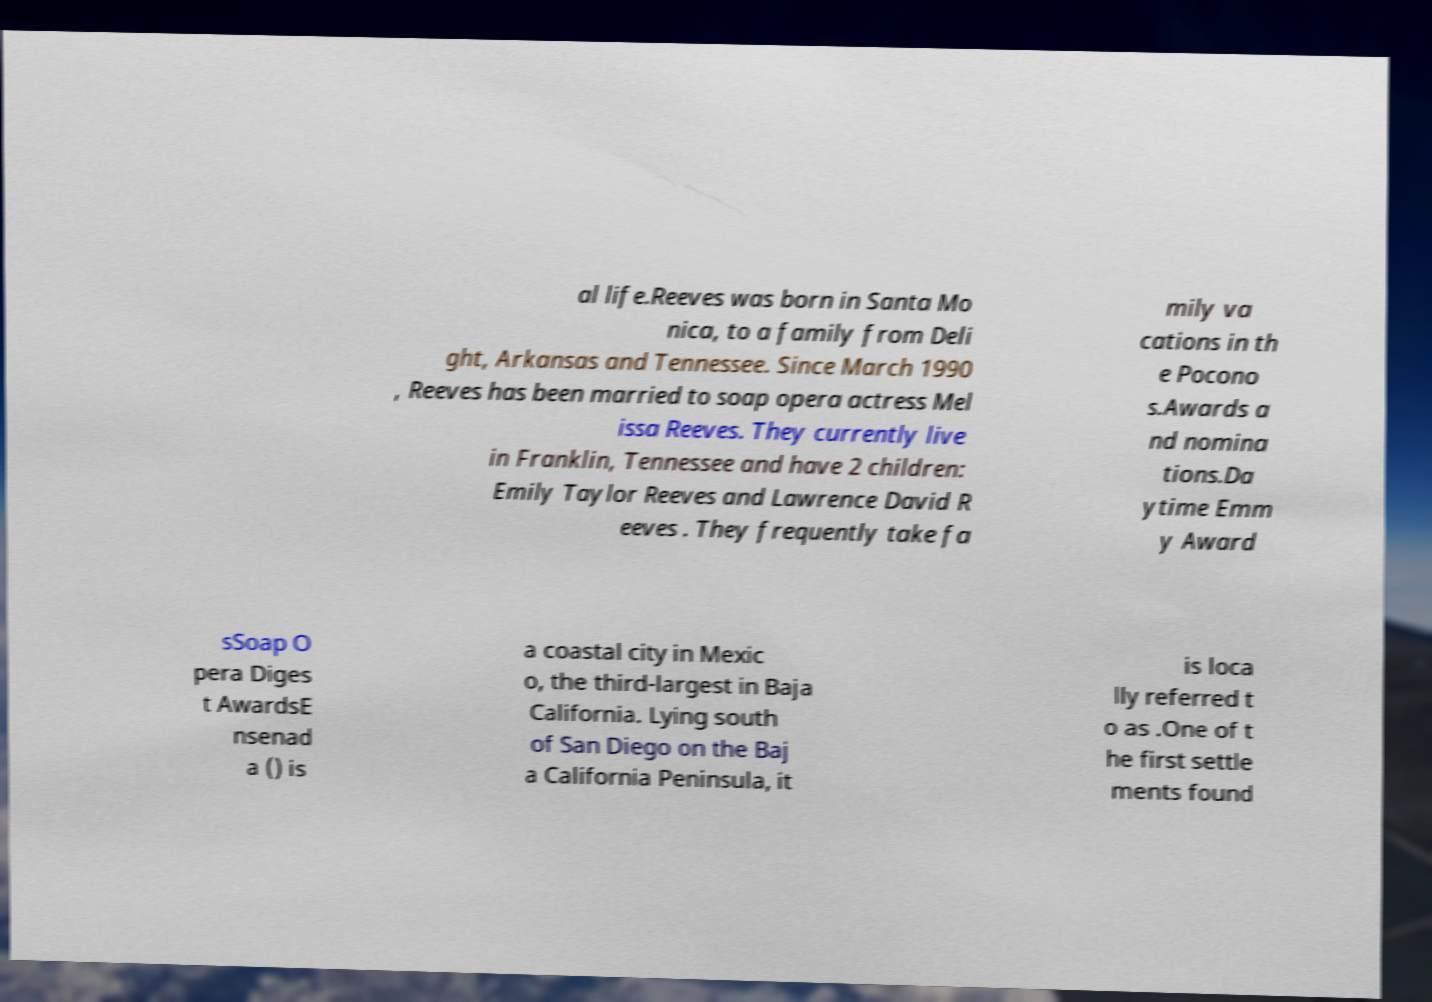Can you accurately transcribe the text from the provided image for me? al life.Reeves was born in Santa Mo nica, to a family from Deli ght, Arkansas and Tennessee. Since March 1990 , Reeves has been married to soap opera actress Mel issa Reeves. They currently live in Franklin, Tennessee and have 2 children: Emily Taylor Reeves and Lawrence David R eeves . They frequently take fa mily va cations in th e Pocono s.Awards a nd nomina tions.Da ytime Emm y Award sSoap O pera Diges t AwardsE nsenad a () is a coastal city in Mexic o, the third-largest in Baja California. Lying south of San Diego on the Baj a California Peninsula, it is loca lly referred t o as .One of t he first settle ments found 